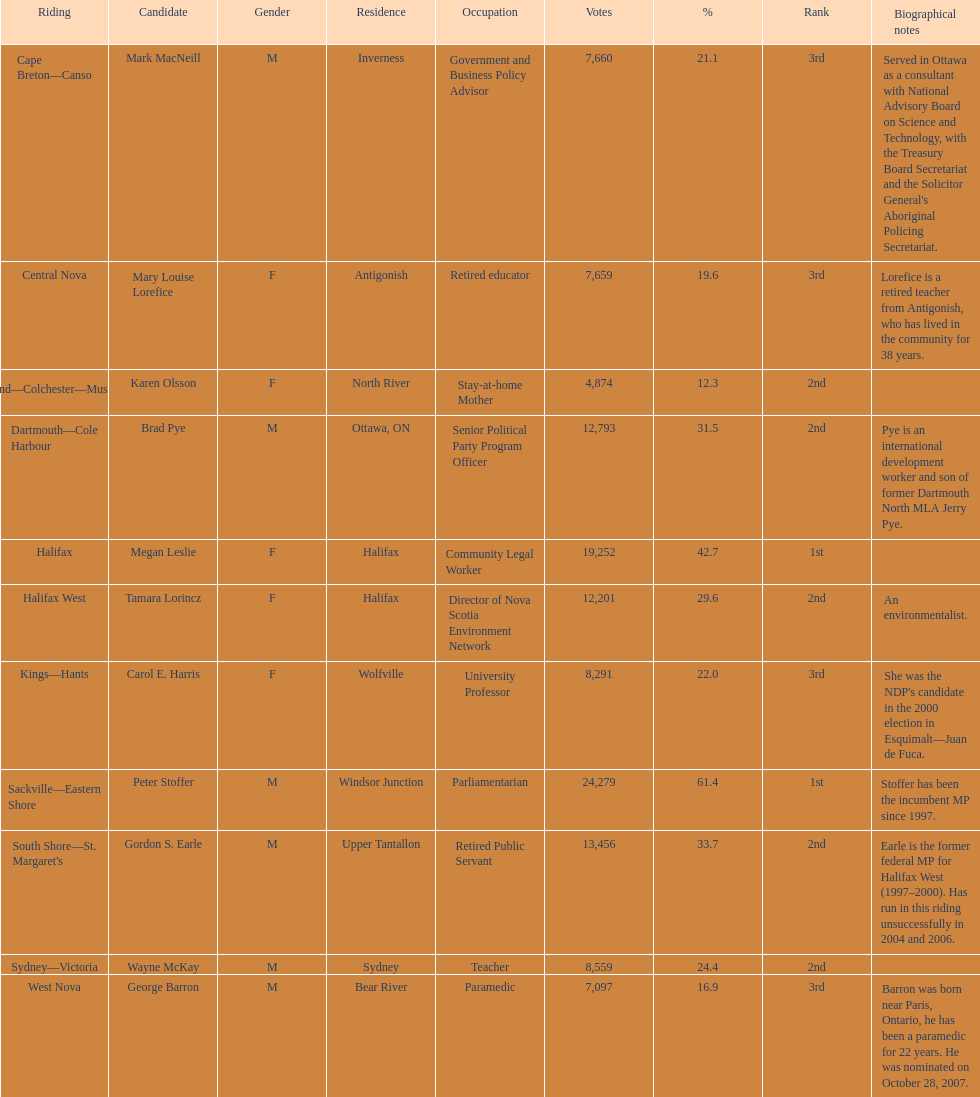Who has the most votes? Sackville-Eastern Shore. 